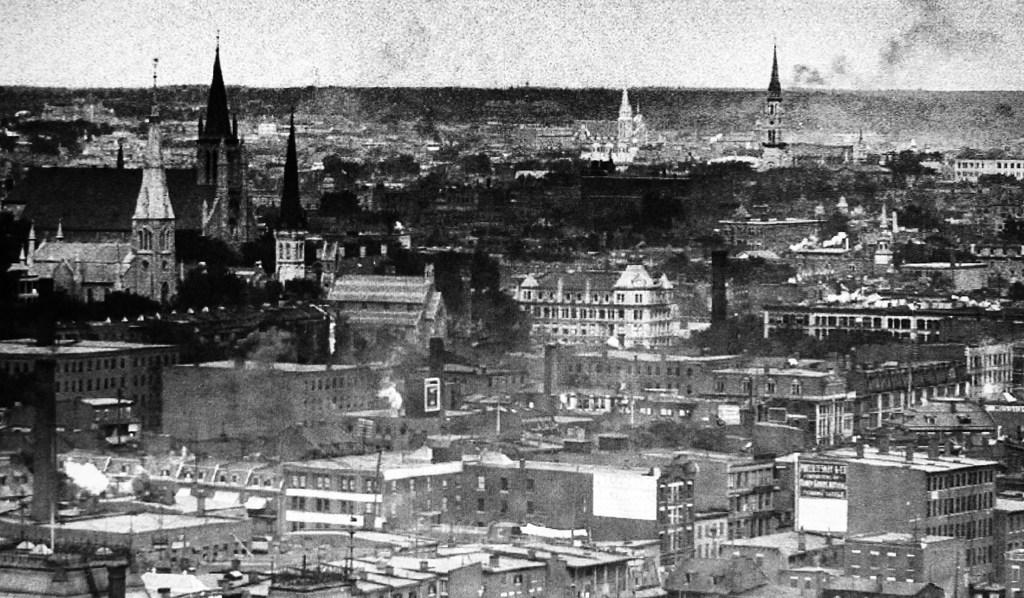What type of structures can be seen in the image? There are buildings in the image. What architectural features can be observed on the buildings? There are windows visible on the buildings. What type of natural environment is present in the image? There are forests and trees in the image. What is the color scheme of the image? The image is in black and white. Can you tell me where the zipper is located on the trees in the image? There are no zippers present on the trees in the image, as trees do not have zippers. 